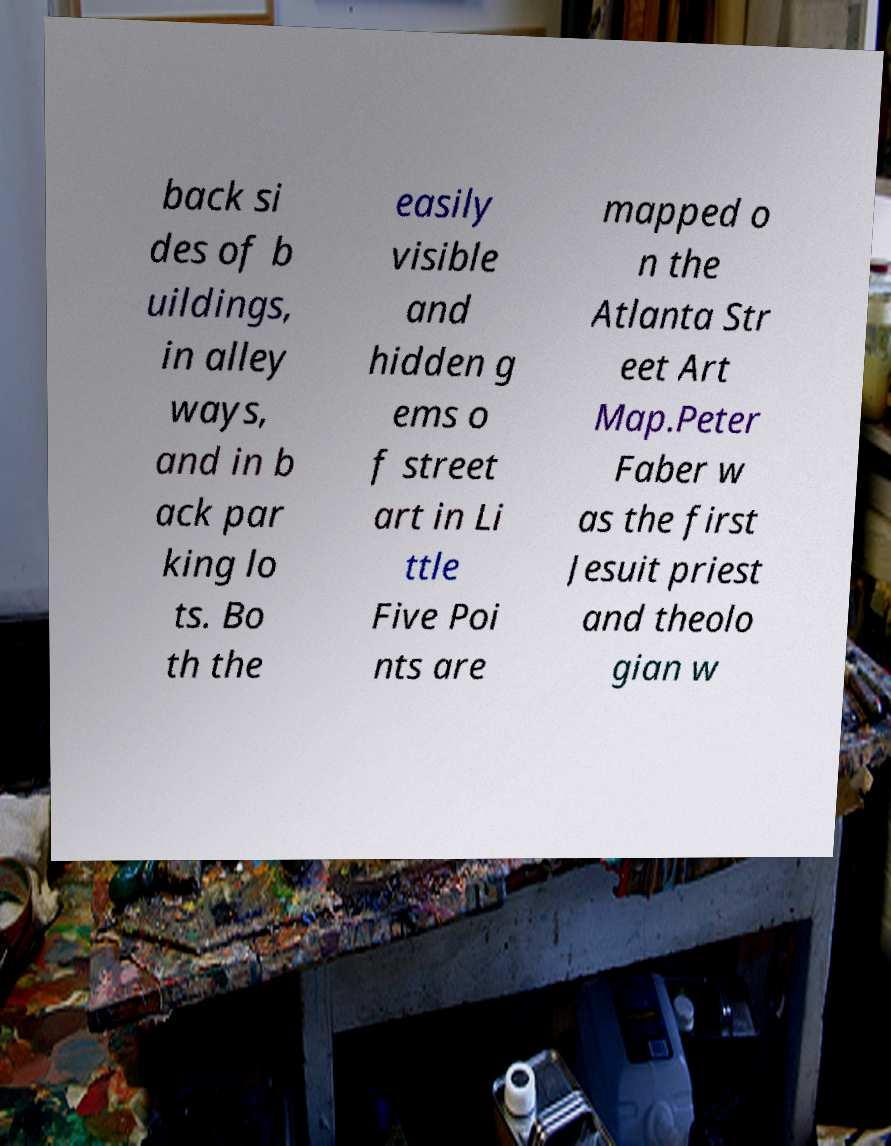Please identify and transcribe the text found in this image. back si des of b uildings, in alley ways, and in b ack par king lo ts. Bo th the easily visible and hidden g ems o f street art in Li ttle Five Poi nts are mapped o n the Atlanta Str eet Art Map.Peter Faber w as the first Jesuit priest and theolo gian w 